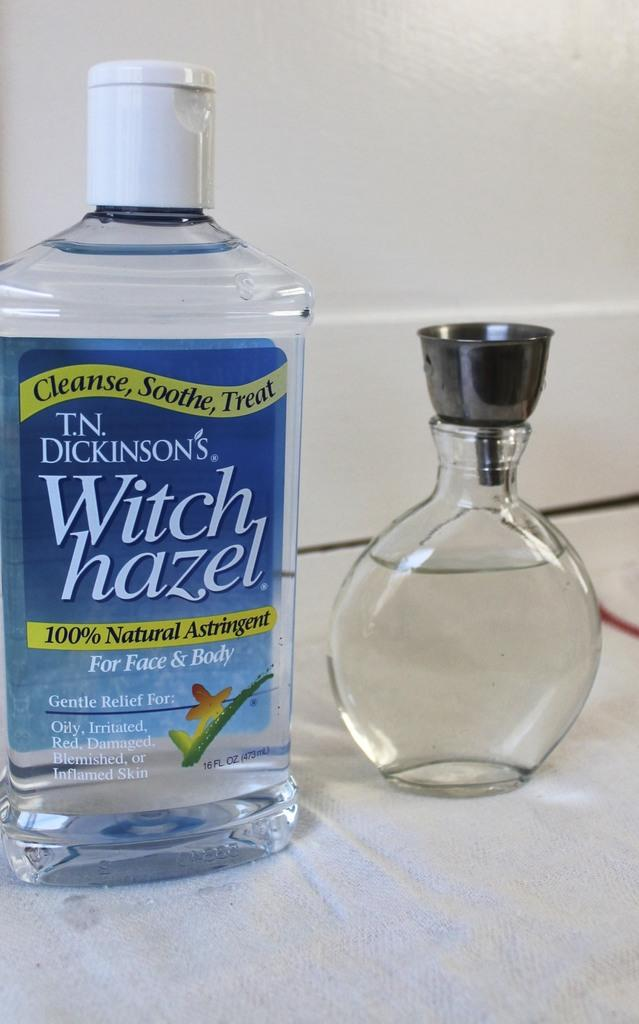<image>
Create a compact narrative representing the image presented. A bottle of witch hazel states it is 100% natural. 